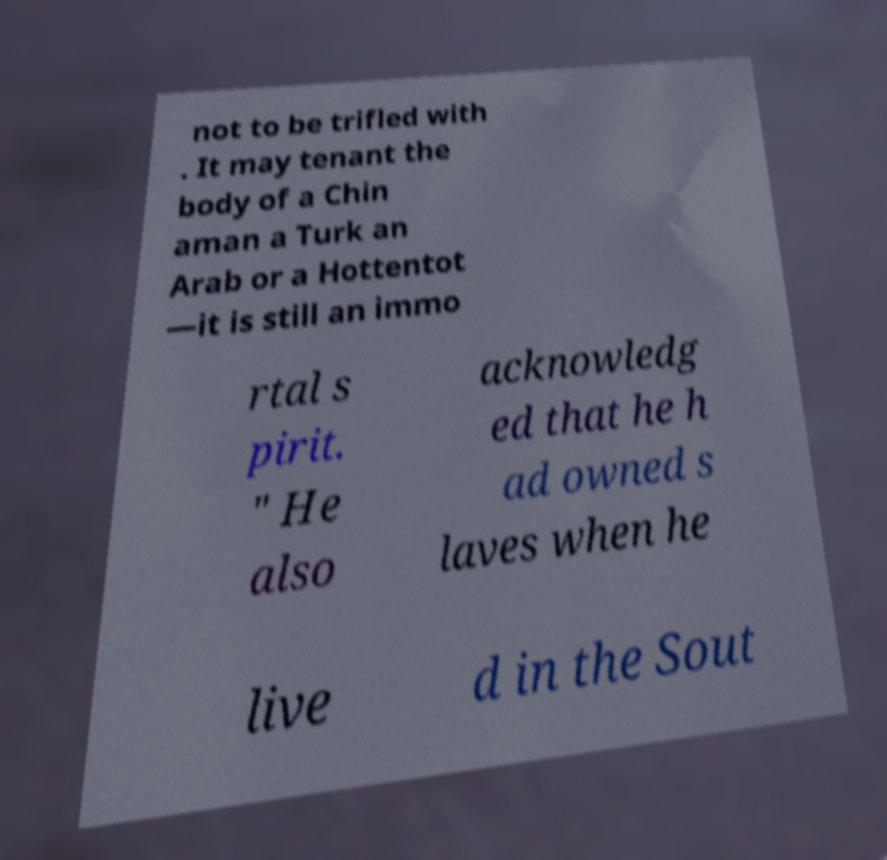Please identify and transcribe the text found in this image. not to be trifled with . It may tenant the body of a Chin aman a Turk an Arab or a Hottentot —it is still an immo rtal s pirit. " He also acknowledg ed that he h ad owned s laves when he live d in the Sout 